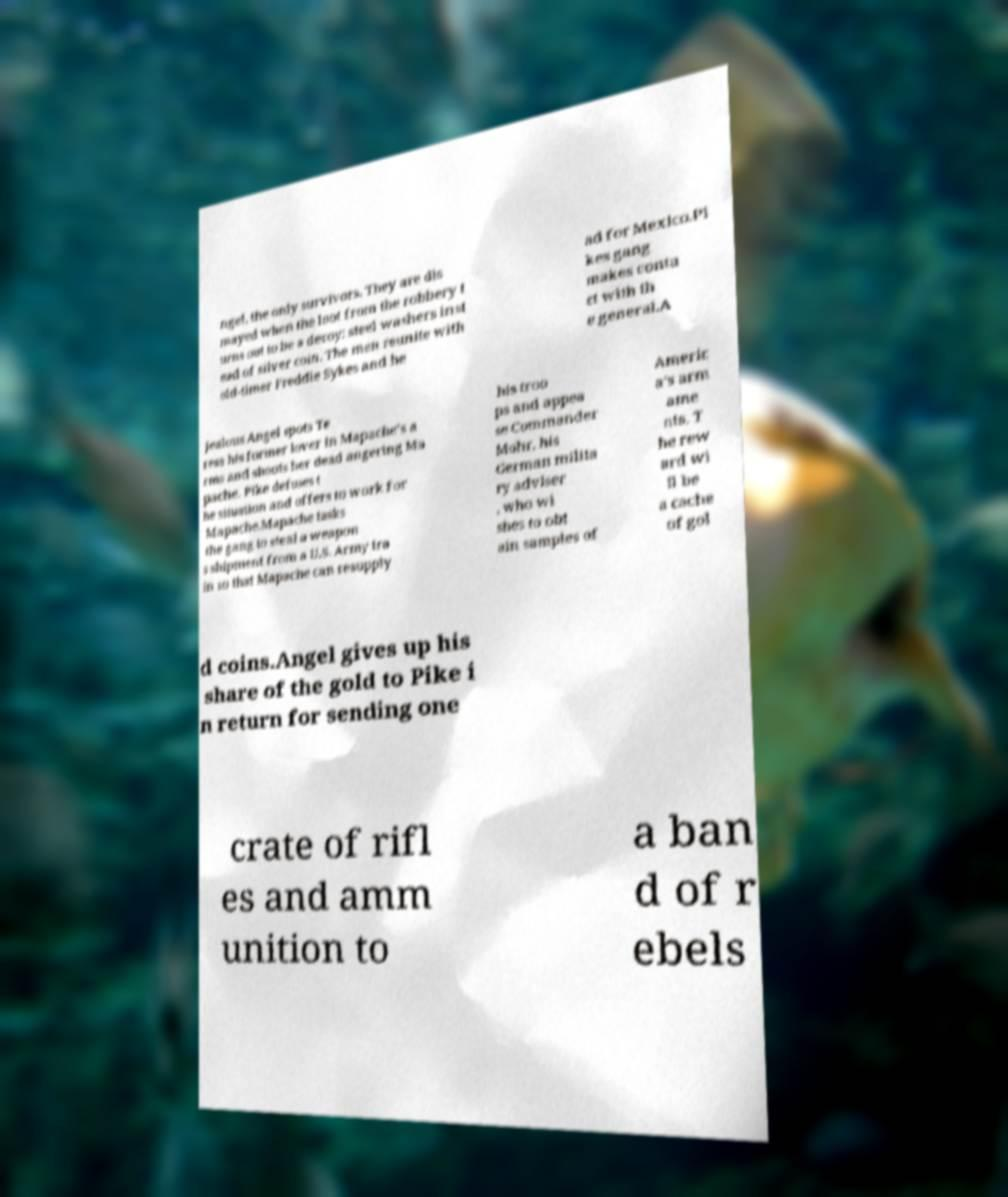I need the written content from this picture converted into text. Can you do that? ngel, the only survivors. They are dis mayed when the loot from the robbery t urns out to be a decoy: steel washers inst ead of silver coin. The men reunite with old-timer Freddie Sykes and he ad for Mexico.Pi kes gang makes conta ct with th e general.A jealous Angel spots Te resa his former lover in Mapache's a rms and shoots her dead angering Ma pache. Pike defuses t he situation and offers to work for Mapache.Mapache tasks the gang to steal a weapon s shipment from a U.S. Army tra in so that Mapache can resupply his troo ps and appea se Commander Mohr, his German milita ry adviser , who wi shes to obt ain samples of Americ a's arm ame nts. T he rew ard wi ll be a cache of gol d coins.Angel gives up his share of the gold to Pike i n return for sending one crate of rifl es and amm unition to a ban d of r ebels 